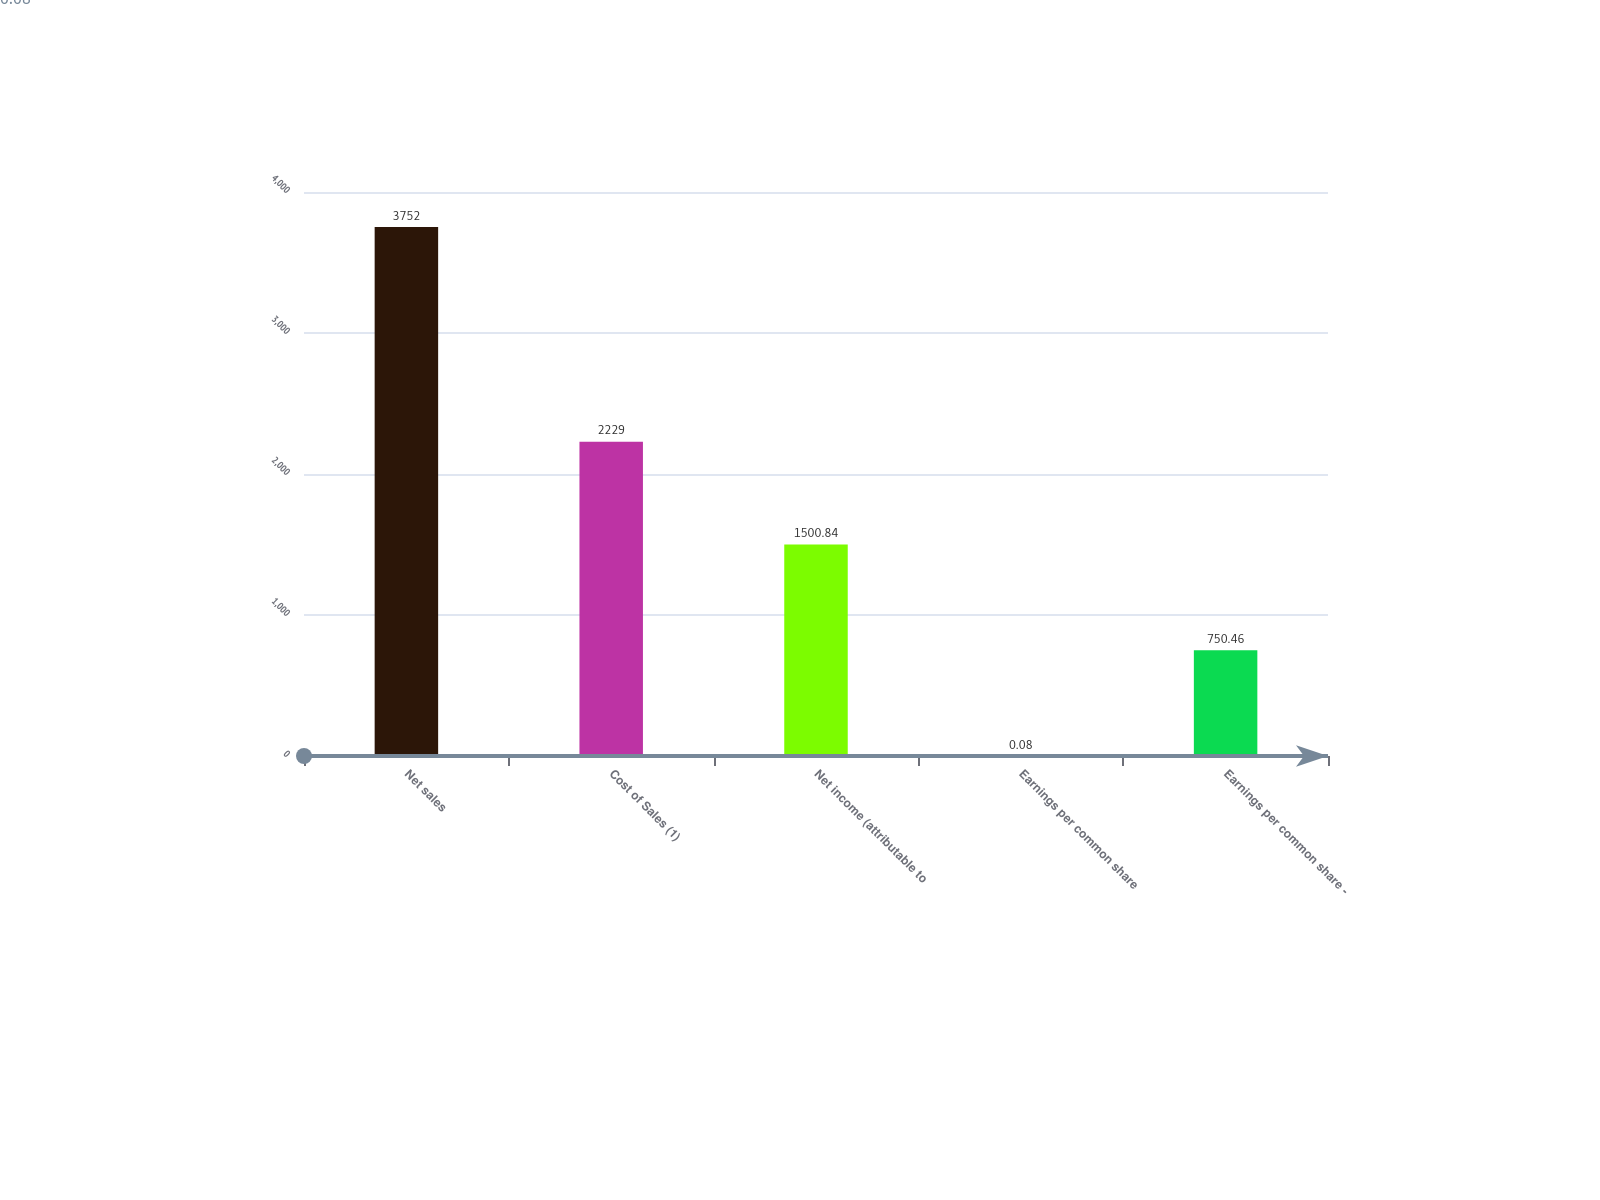Convert chart. <chart><loc_0><loc_0><loc_500><loc_500><bar_chart><fcel>Net sales<fcel>Cost of Sales (1)<fcel>Net income (attributable to<fcel>Earnings per common share<fcel>Earnings per common share -<nl><fcel>3752<fcel>2229<fcel>1500.84<fcel>0.08<fcel>750.46<nl></chart> 